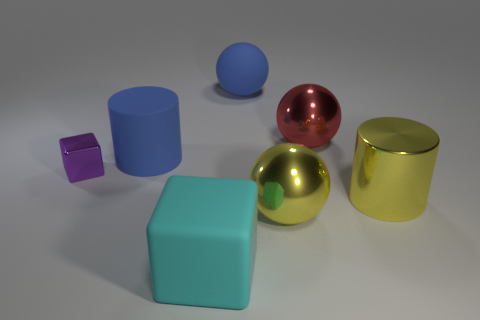What is the shape of the cyan thing that is the same size as the yellow metal cylinder?
Provide a short and direct response. Cube. Are there any cyan rubber objects that have the same shape as the small purple object?
Offer a terse response. Yes. There is a yellow object that is right of the red shiny object; is it the same size as the cyan cube?
Your answer should be compact. Yes. There is a thing that is left of the rubber cube and to the right of the tiny purple thing; what size is it?
Provide a short and direct response. Large. How many other objects are there of the same material as the big cyan cube?
Your answer should be compact. 2. What is the size of the sphere behind the red shiny object?
Make the answer very short. Large. Is the color of the matte sphere the same as the rubber cylinder?
Provide a short and direct response. Yes. How many large objects are matte objects or metallic spheres?
Keep it short and to the point. 5. Is there any other thing of the same color as the big matte cylinder?
Make the answer very short. Yes. There is a cyan object; are there any blocks right of it?
Offer a terse response. No. 